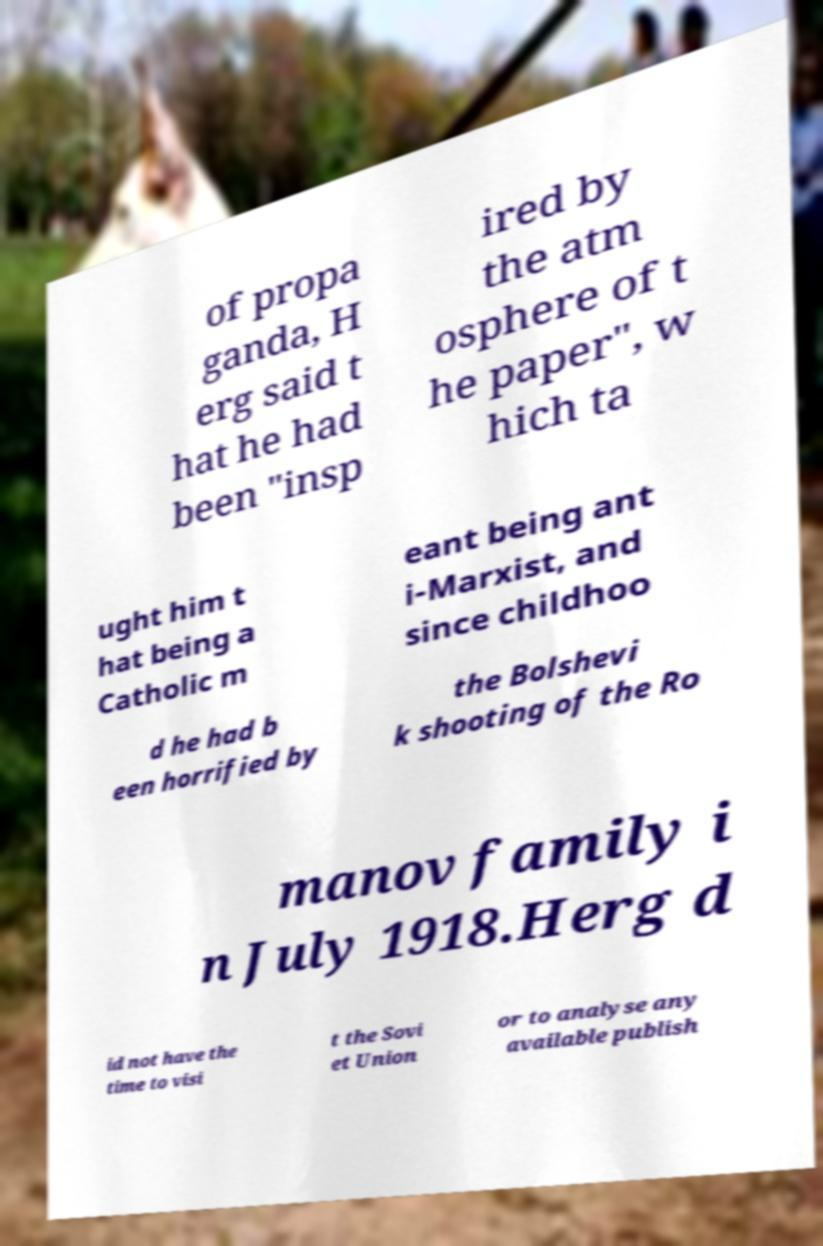For documentation purposes, I need the text within this image transcribed. Could you provide that? of propa ganda, H erg said t hat he had been "insp ired by the atm osphere of t he paper", w hich ta ught him t hat being a Catholic m eant being ant i-Marxist, and since childhoo d he had b een horrified by the Bolshevi k shooting of the Ro manov family i n July 1918.Herg d id not have the time to visi t the Sovi et Union or to analyse any available publish 